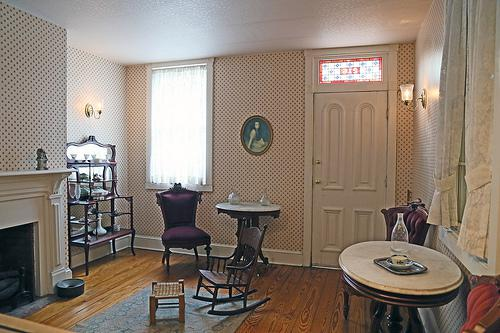Question: where is the oil lamp?
Choices:
A. On the table.
B. On the counter.
C. On the end table.
D. In the closet.
Answer with the letter. Answer: A Question: what time of day is it?
Choices:
A. Three o'clock.
B. Noon.
C. Day time.
D. Dawn.
Answer with the letter. Answer: C Question: where is purple chair?
Choices:
A. In the corner.
B. Next to the couch.
C. By the door.
D. Under the window.
Answer with the letter. Answer: D 